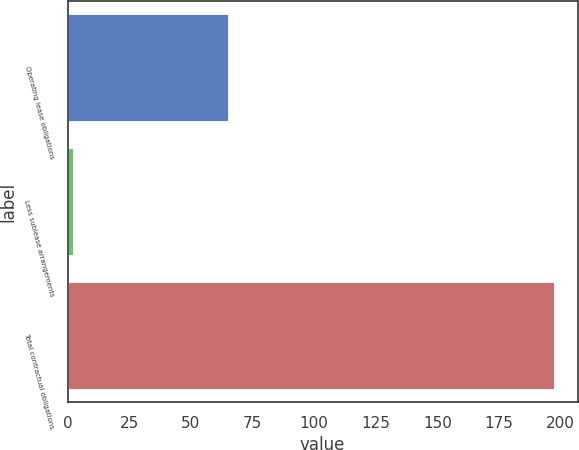Convert chart. <chart><loc_0><loc_0><loc_500><loc_500><bar_chart><fcel>Operating lease obligations<fcel>Less sublease arrangements<fcel>Total contractual obligations<nl><fcel>65.2<fcel>2.3<fcel>197.1<nl></chart> 